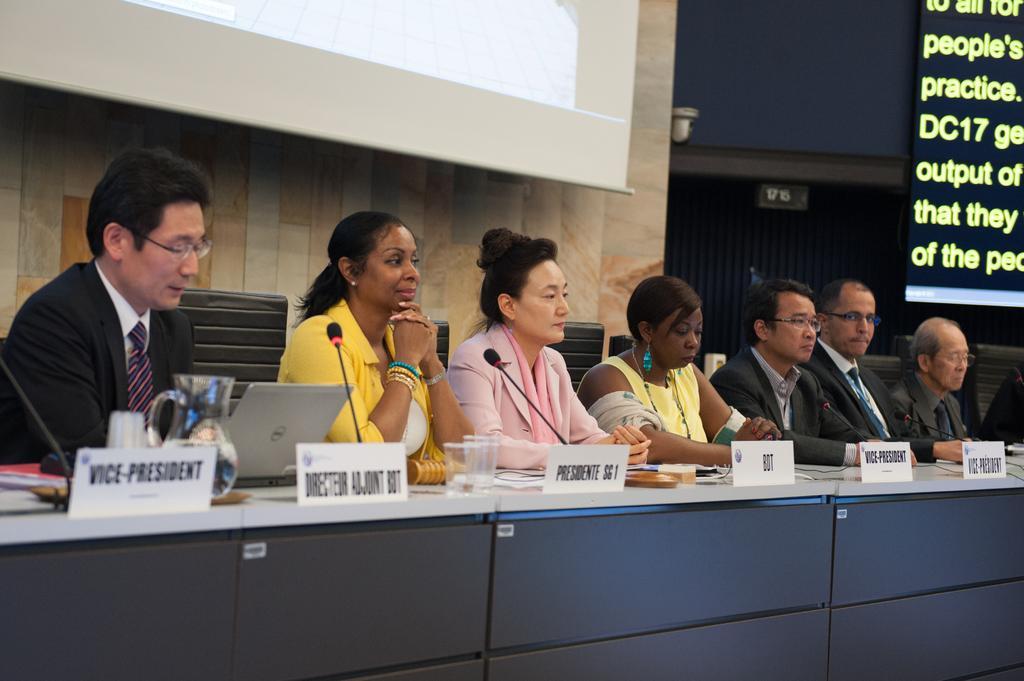Could you give a brief overview of what you see in this image? In this image, I can see seven persons sitting on the chairs. There is a table with a laptop, mike's, name boards, water jug, glasses and few other objects. In the background, I can see two screens and there is a wall. 